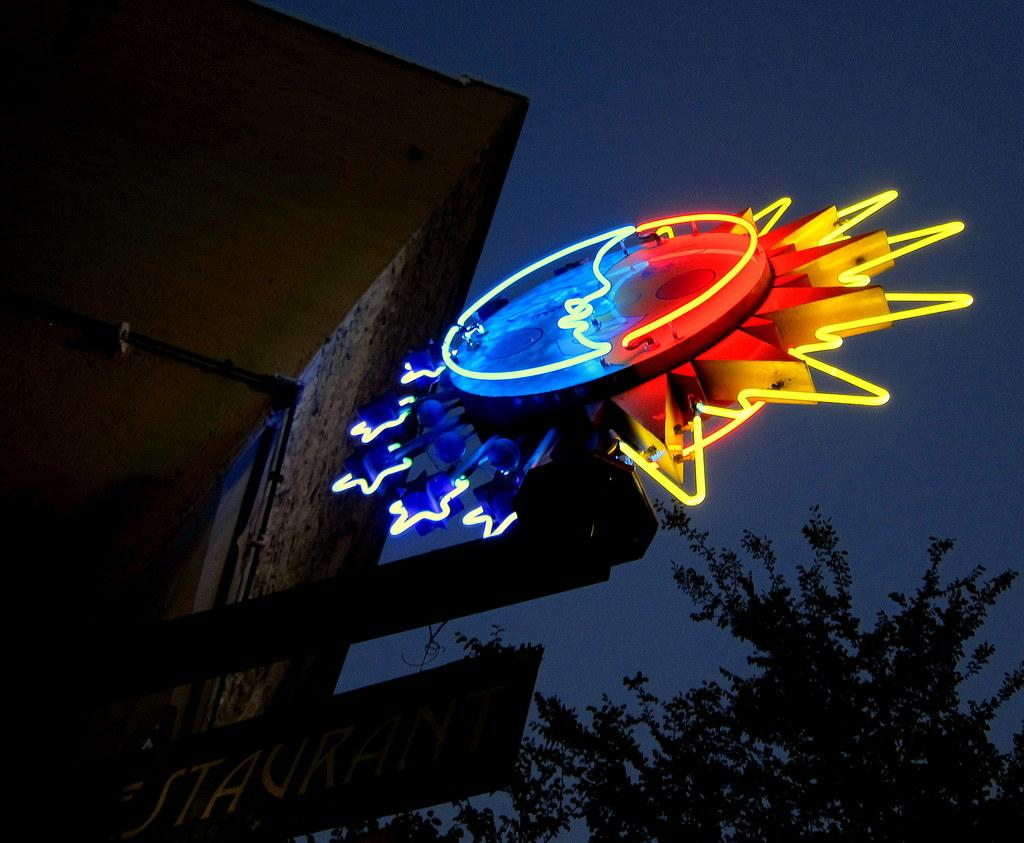What is the main object in the image? There is a name board in the image. What other objects can be seen in the image? There is a tree and rods visible in the image. Can you describe the object in the image? There is an object in the image, but its specific details are not mentioned in the facts. What can be seen in the background of the image? The sky is visible in the background of the image. What type of slip can be seen on the tree in the image? There is no slip present on the tree in the image. How does the health of the object in the image affect its appearance? The facts do not mention any information about the health of the object in the image, so we cannot determine its effect on the object's appearance. 